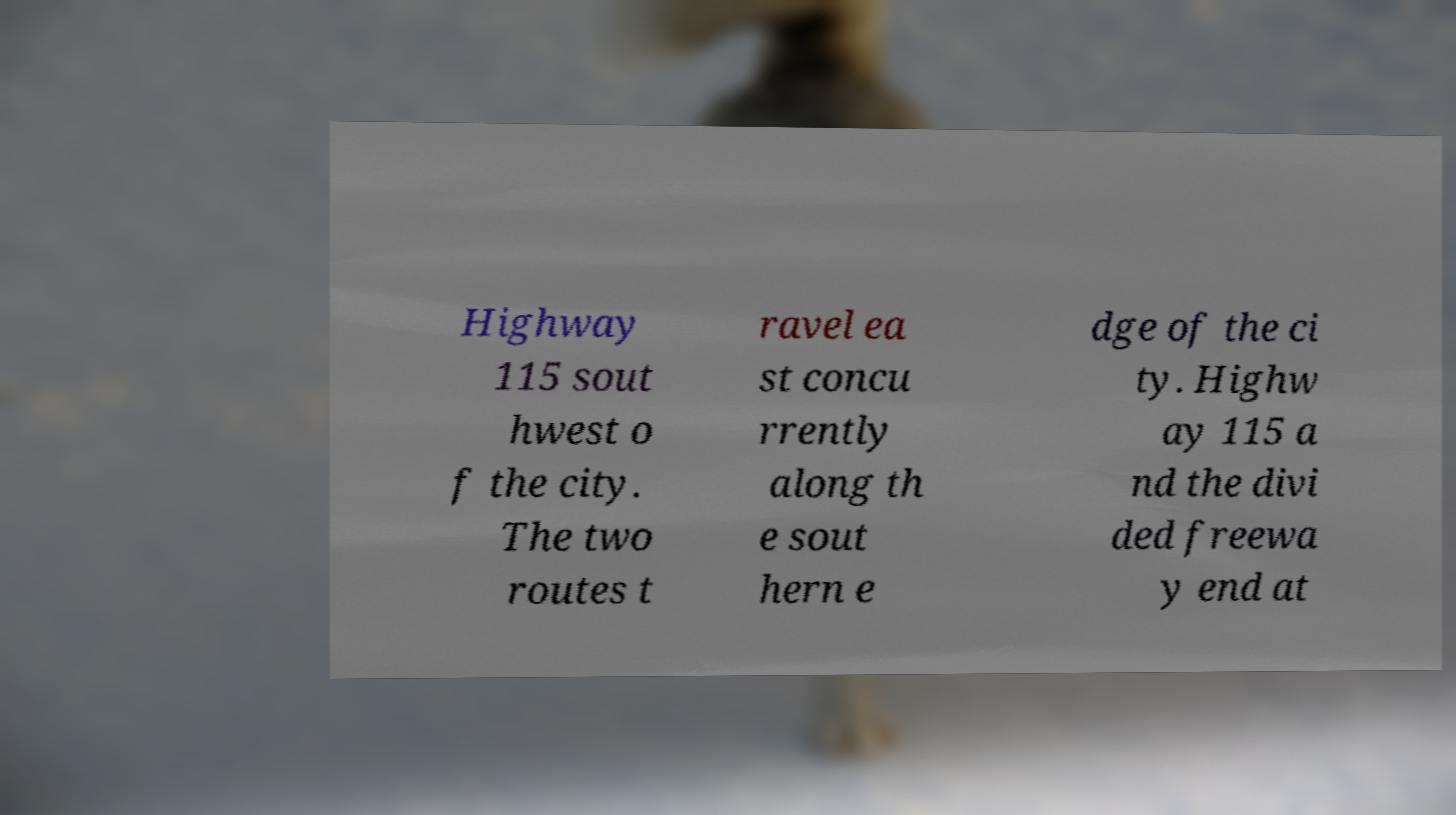Could you assist in decoding the text presented in this image and type it out clearly? Highway 115 sout hwest o f the city. The two routes t ravel ea st concu rrently along th e sout hern e dge of the ci ty. Highw ay 115 a nd the divi ded freewa y end at 